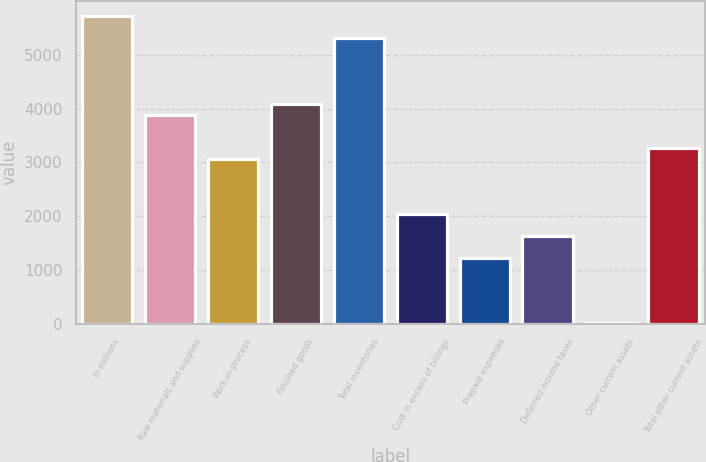Convert chart. <chart><loc_0><loc_0><loc_500><loc_500><bar_chart><fcel>In millions<fcel>Raw materials and supplies<fcel>Work-in-process<fcel>Finished goods<fcel>Total inventories<fcel>Cost in excess of billings<fcel>Prepaid expenses<fcel>Deferred income taxes<fcel>Other current assets<fcel>Total other current assets<nl><fcel>5708.8<fcel>3878.2<fcel>3064.6<fcel>4081.6<fcel>5302<fcel>2047.6<fcel>1234<fcel>1640.8<fcel>13.6<fcel>3268<nl></chart> 